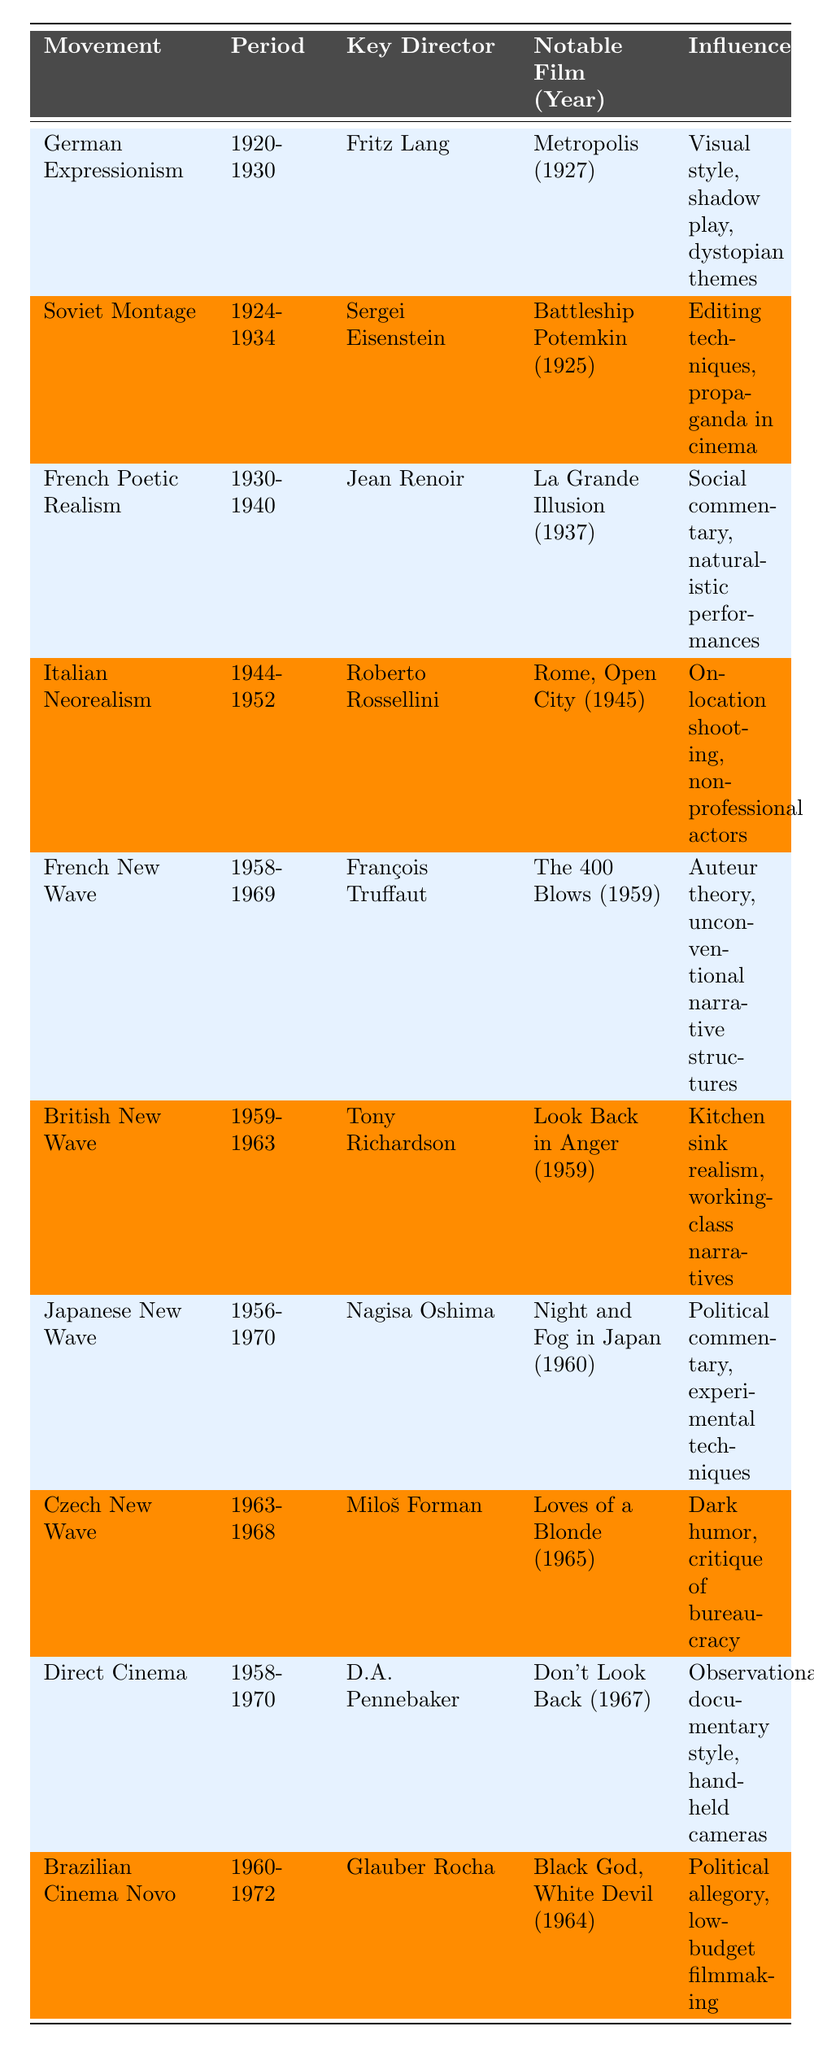What is the notable film associated with Italian Neorealism? The table lists "Rome, Open City" as the notable film for Italian Neorealism, directed by Roberto Rossellini in 1945.
Answer: Rome, Open City Which director is known for the key film "Battleship Potemkin"? According to the table, Sergei Eisenstein is the key director associated with "Battleship Potemkin," released in 1925.
Answer: Sergei Eisenstein In what period did the French New Wave occur? The table indicates that the French New Wave movement occurred between 1958 and 1969.
Answer: 1958-1969 True or False: Jean Renoir directed films during the German Expressionism movement. The table clearly states that Jean Renoir is linked to French Poetic Realism, not German Expressionism. Therefore, the answer is false.
Answer: False How many movements listed in the table were active during the 1960s? The table shows the movements "French New Wave," "British New Wave," "Japanese New Wave," "Czech New Wave," "Direct Cinema," and "Brazilian Cinema Novo," which indicates a total of 6 movements that were active during the 1960s.
Answer: 6 What influence is shared by both French New Wave and Japanese New Wave? The table shows that both movements involve strong political commentary and challenge traditional narrative structures, focusing on experimental techniques.
Answer: Political commentary and experimental techniques Which director is associated with the influence of "editing techniques and propaganda in cinema"? The table shows that this influence is attributed to Sergei Eisenstein, the key director of the Soviet Montage movement.
Answer: Sergei Eisenstein What notable film from the Czech New Wave is known for its dark humor? According to the table, "Loves of a Blonde" is the notable film from the Czech New Wave, characterized by dark humor and critique of bureaucracy.
Answer: Loves of a Blonde Identify the earliest film listed in the table and its associated movement. The table lists "Battleship Potemkin" from 1925 under the Soviet Montage movement, which is the earliest film mentioned.
Answer: Battleship Potemkin, Soviet Montage How many movements are characterized by political commentary? From the data in the table, both Brazilian Cinema Novo and Japanese New Wave are characterized by political commentary, totaling 2 movements.
Answer: 2 